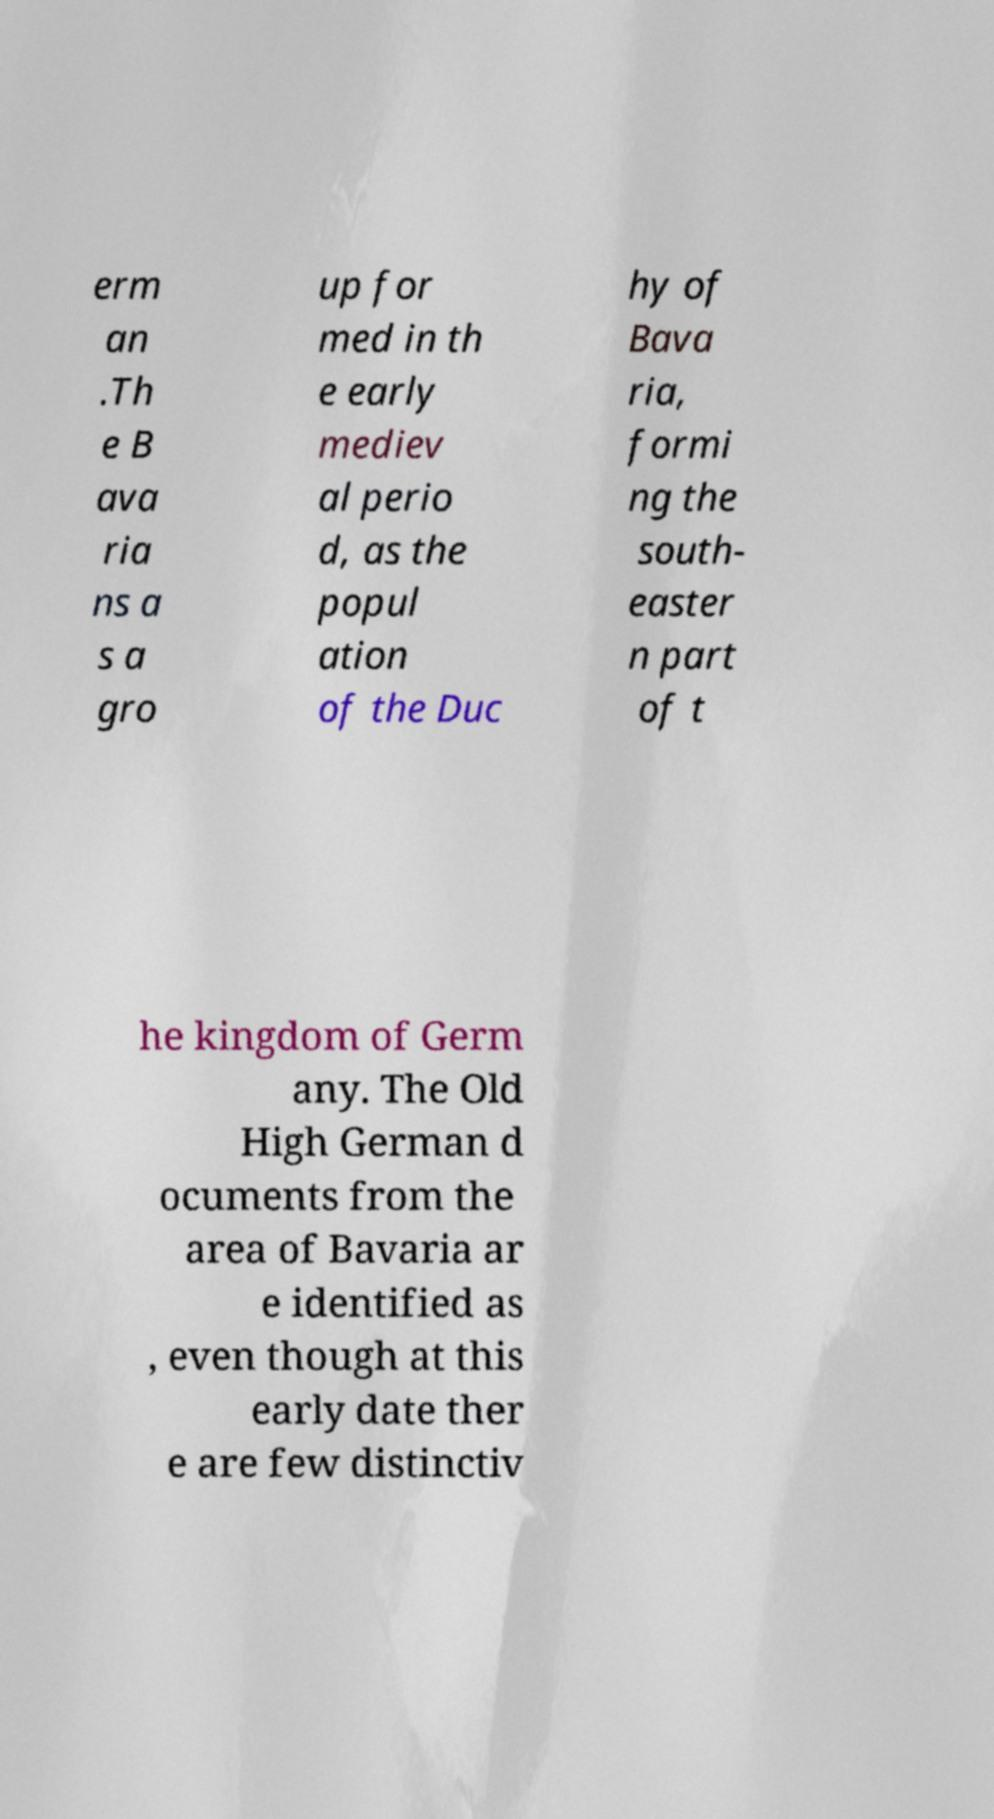Can you accurately transcribe the text from the provided image for me? erm an .Th e B ava ria ns a s a gro up for med in th e early mediev al perio d, as the popul ation of the Duc hy of Bava ria, formi ng the south- easter n part of t he kingdom of Germ any. The Old High German d ocuments from the area of Bavaria ar e identified as , even though at this early date ther e are few distinctiv 